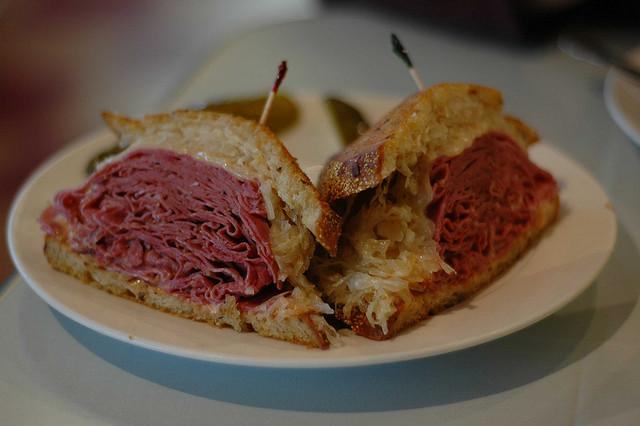What's the purpose of the little sticks? Please explain your reasoning. keep together. The purpose is to hold together. 